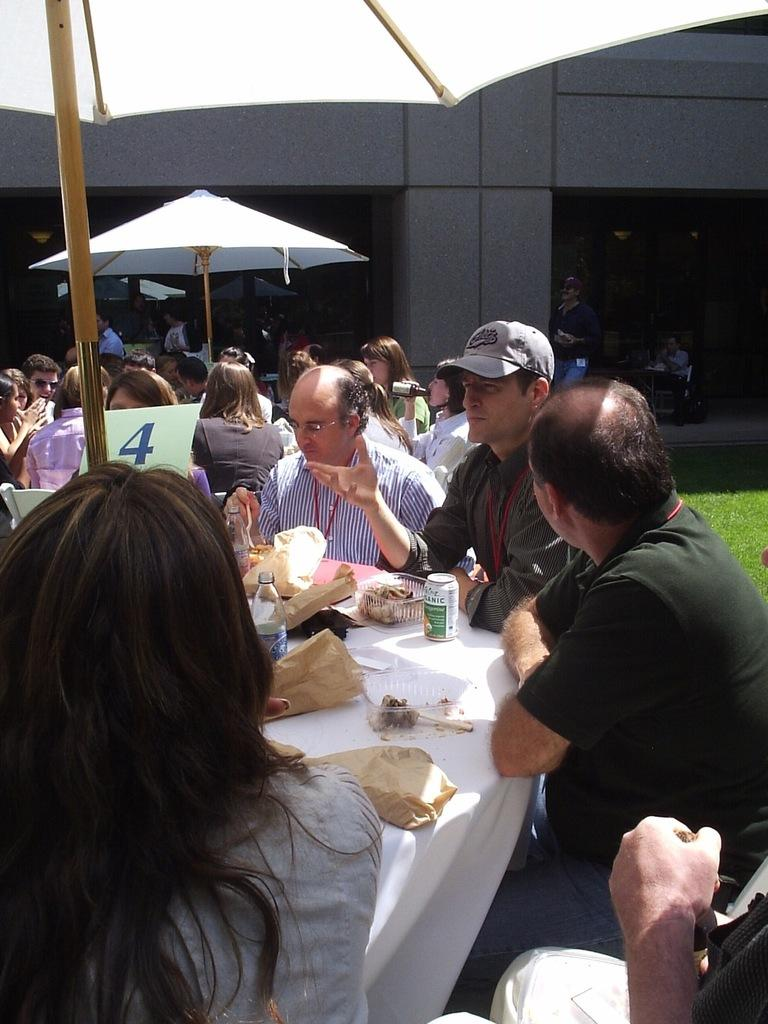Who is present in the image? There are people in the image. How are the people arranged in the image? The people are sitting in groups. Where are the groups of people located in the image? The groups are around tables. What type of location is depicted in the image? The setting is a restaurant. What type of lace can be seen on the tablecloths in the image? There is no mention of tablecloths or lace in the provided facts, so it cannot be determined from the image. 